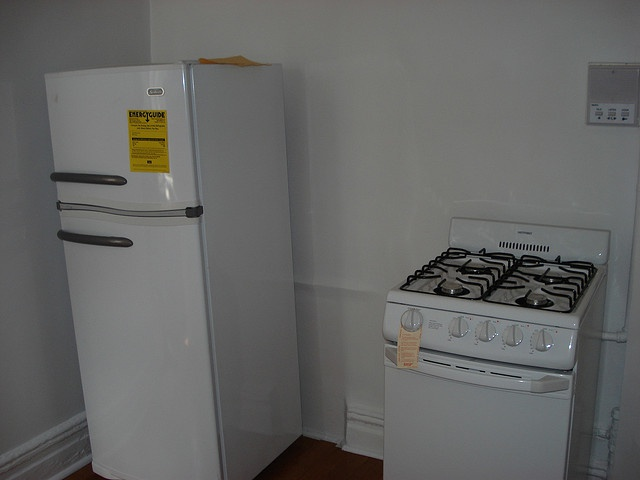Describe the objects in this image and their specific colors. I can see refrigerator in black, gray, and olive tones and oven in black and gray tones in this image. 